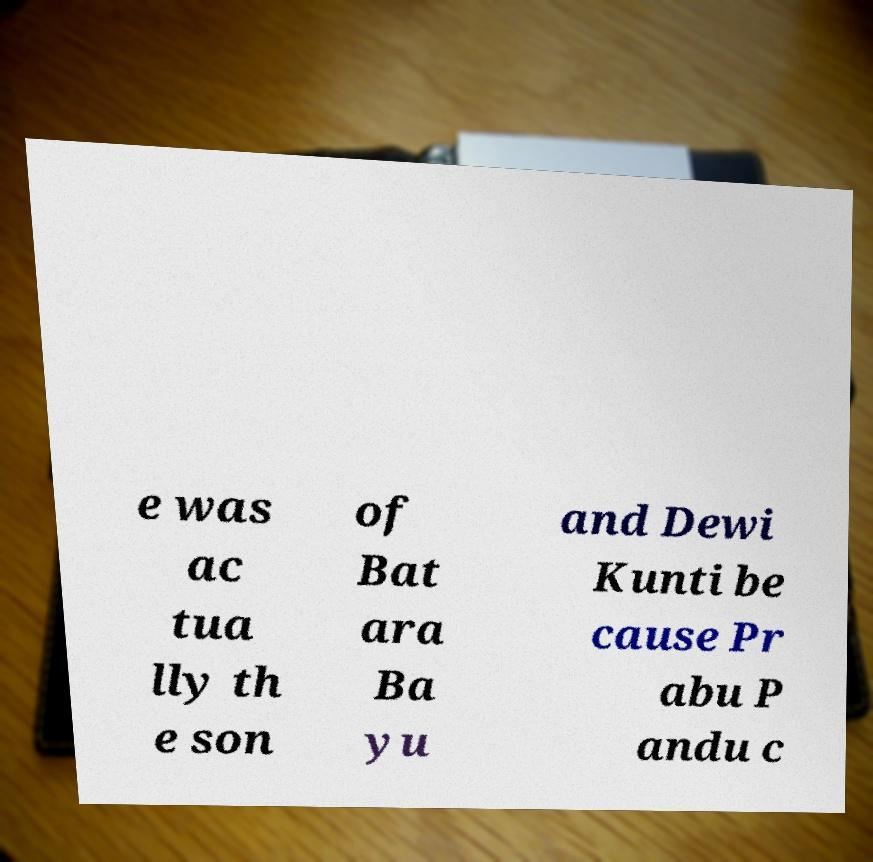There's text embedded in this image that I need extracted. Can you transcribe it verbatim? e was ac tua lly th e son of Bat ara Ba yu and Dewi Kunti be cause Pr abu P andu c 